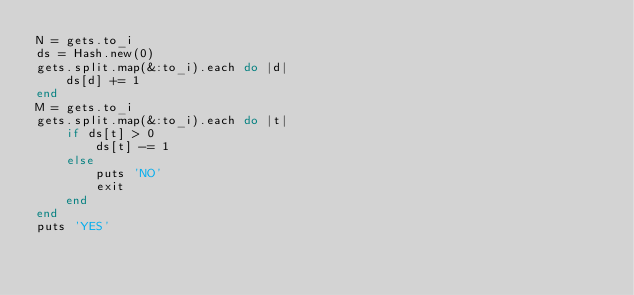<code> <loc_0><loc_0><loc_500><loc_500><_Ruby_>N = gets.to_i
ds = Hash.new(0)
gets.split.map(&:to_i).each do |d|
    ds[d] += 1
end
M = gets.to_i
gets.split.map(&:to_i).each do |t|
    if ds[t] > 0
        ds[t] -= 1
    else
        puts 'NO'
        exit
    end
end
puts 'YES'</code> 